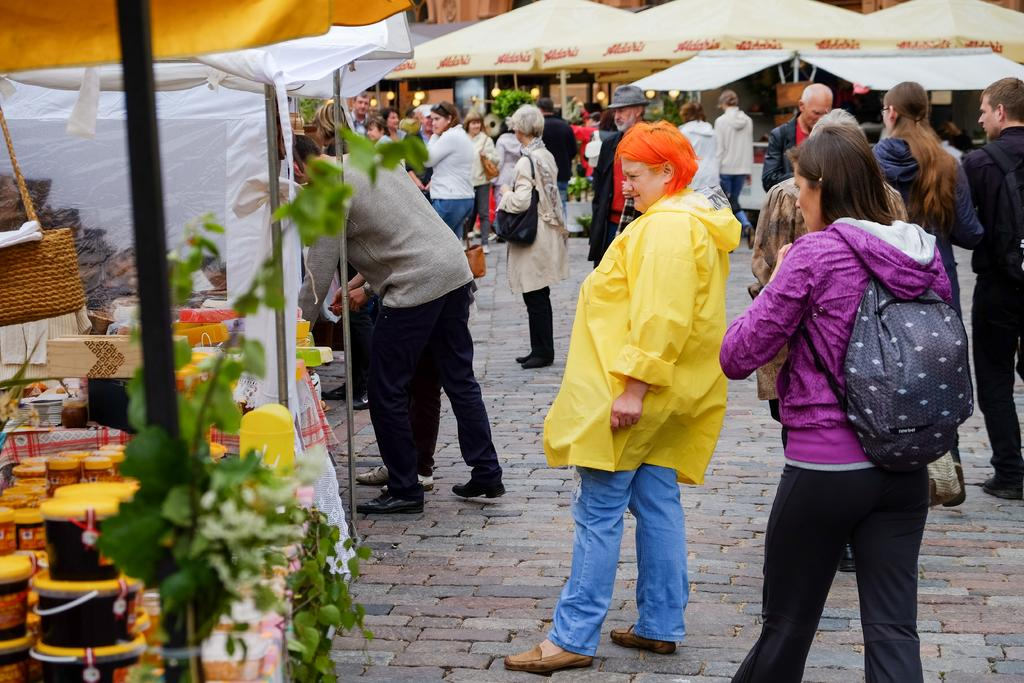What can be seen on the road in the image? There is a group of people on the road in the image. What type of vegetation is present in the image? There are plants in the image. What objects in the image provide illumination? There are lights in the image. What items in the image are used for storage or packaging? There are boxes in the image. What can be seen in the image that is used for holding liquids? There are bottles in the image. What structures are present in the image that support or hold other objects? There are poles in the image. What objects in the image provide protection from the sun or rain? There are umbrellas in the image. What type of sign can be seen in the image? There is no sign present in the image. What type of dress is being worn by the people in the image? The provided facts do not mention any specific clothing or dress worn by the people in the image. 